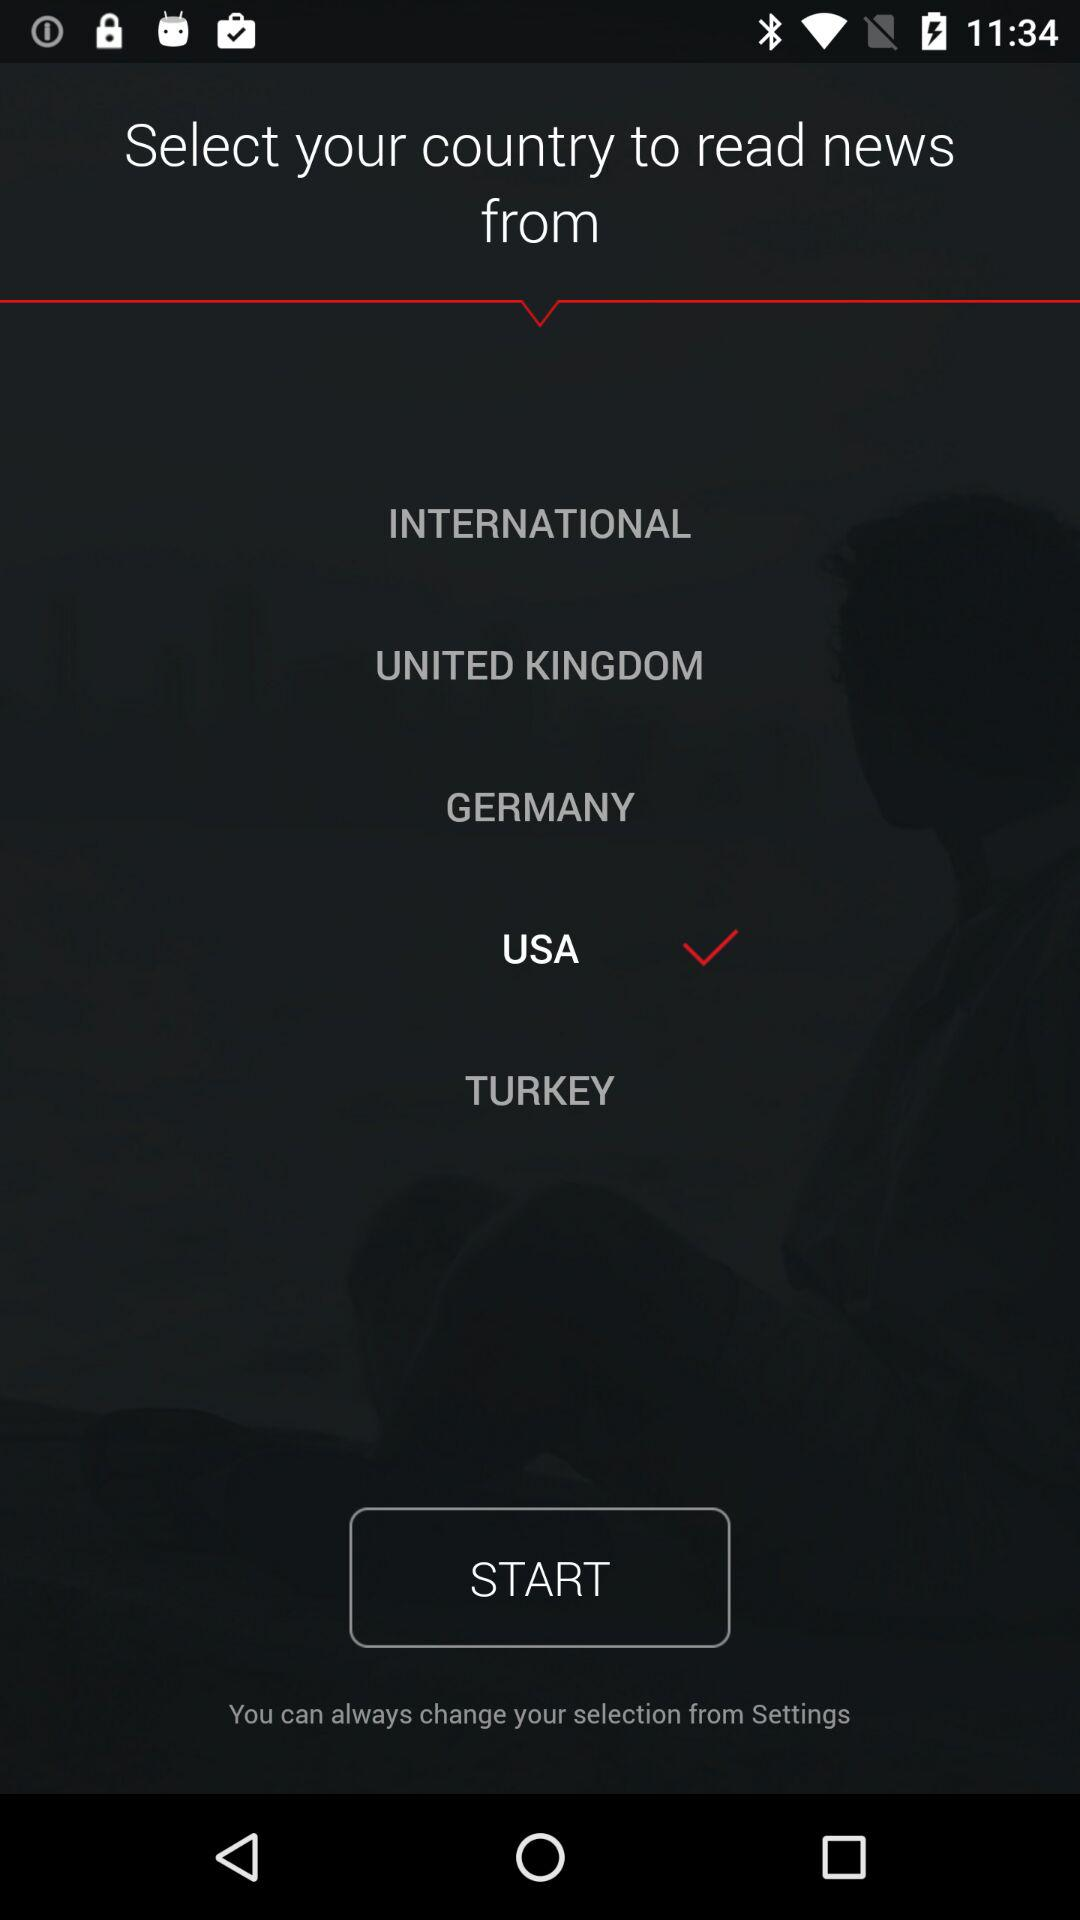What is the selected country? The selected country is the USA. 